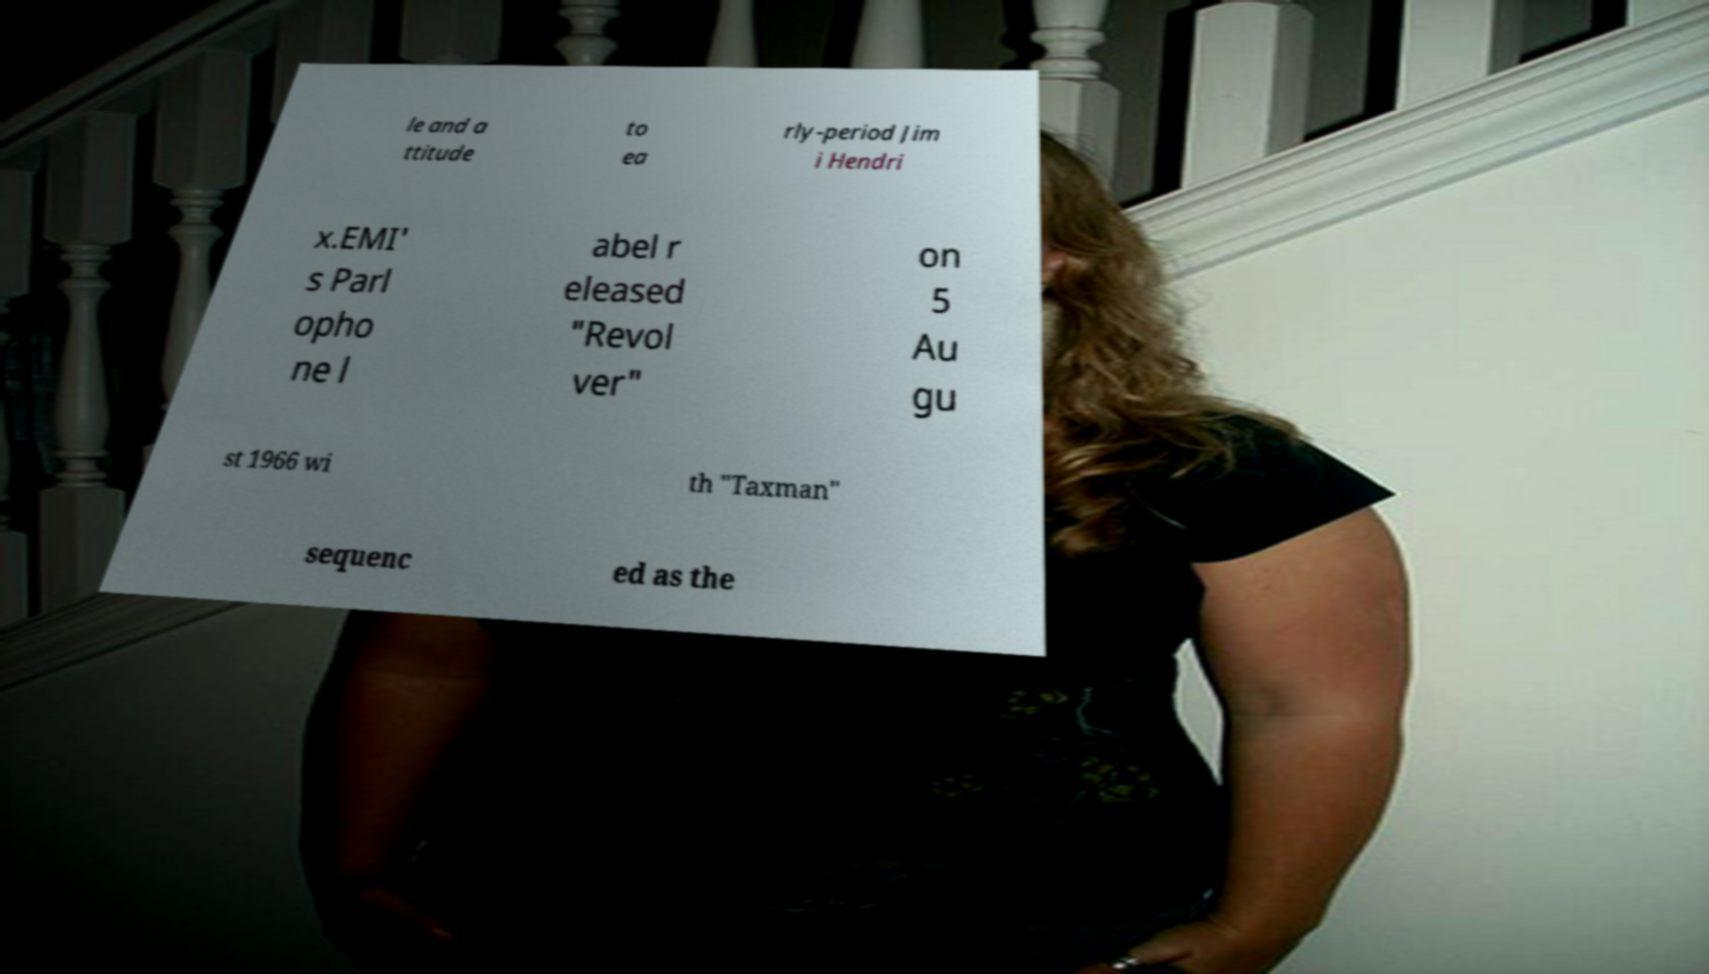Could you extract and type out the text from this image? le and a ttitude to ea rly-period Jim i Hendri x.EMI' s Parl opho ne l abel r eleased "Revol ver" on 5 Au gu st 1966 wi th "Taxman" sequenc ed as the 